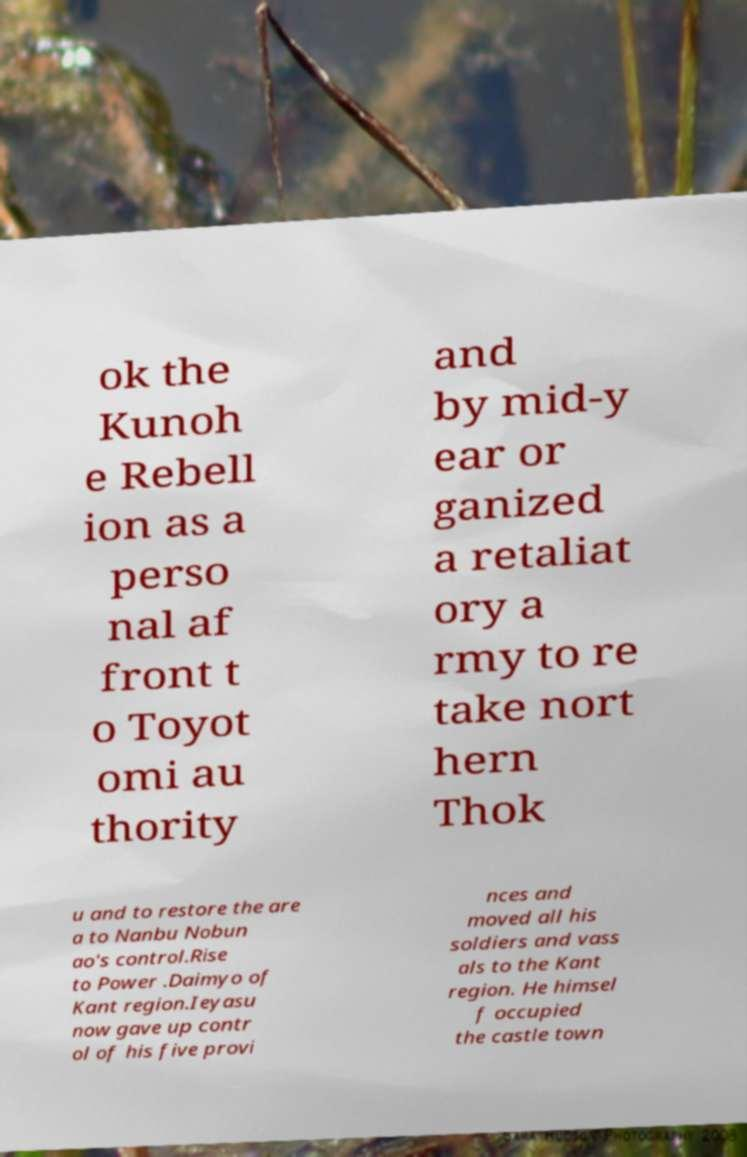Could you extract and type out the text from this image? ok the Kunoh e Rebell ion as a perso nal af front t o Toyot omi au thority and by mid-y ear or ganized a retaliat ory a rmy to re take nort hern Thok u and to restore the are a to Nanbu Nobun ao's control.Rise to Power .Daimyo of Kant region.Ieyasu now gave up contr ol of his five provi nces and moved all his soldiers and vass als to the Kant region. He himsel f occupied the castle town 